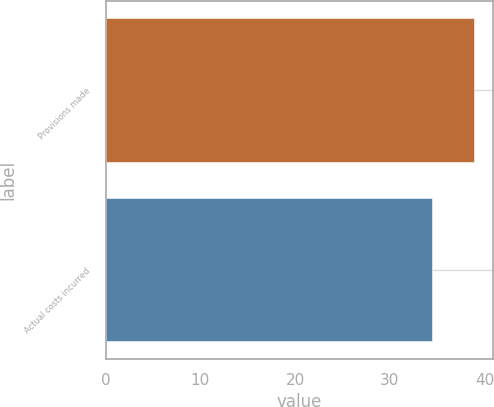Convert chart. <chart><loc_0><loc_0><loc_500><loc_500><bar_chart><fcel>Provisions made<fcel>Actual costs incurred<nl><fcel>38.9<fcel>34.4<nl></chart> 